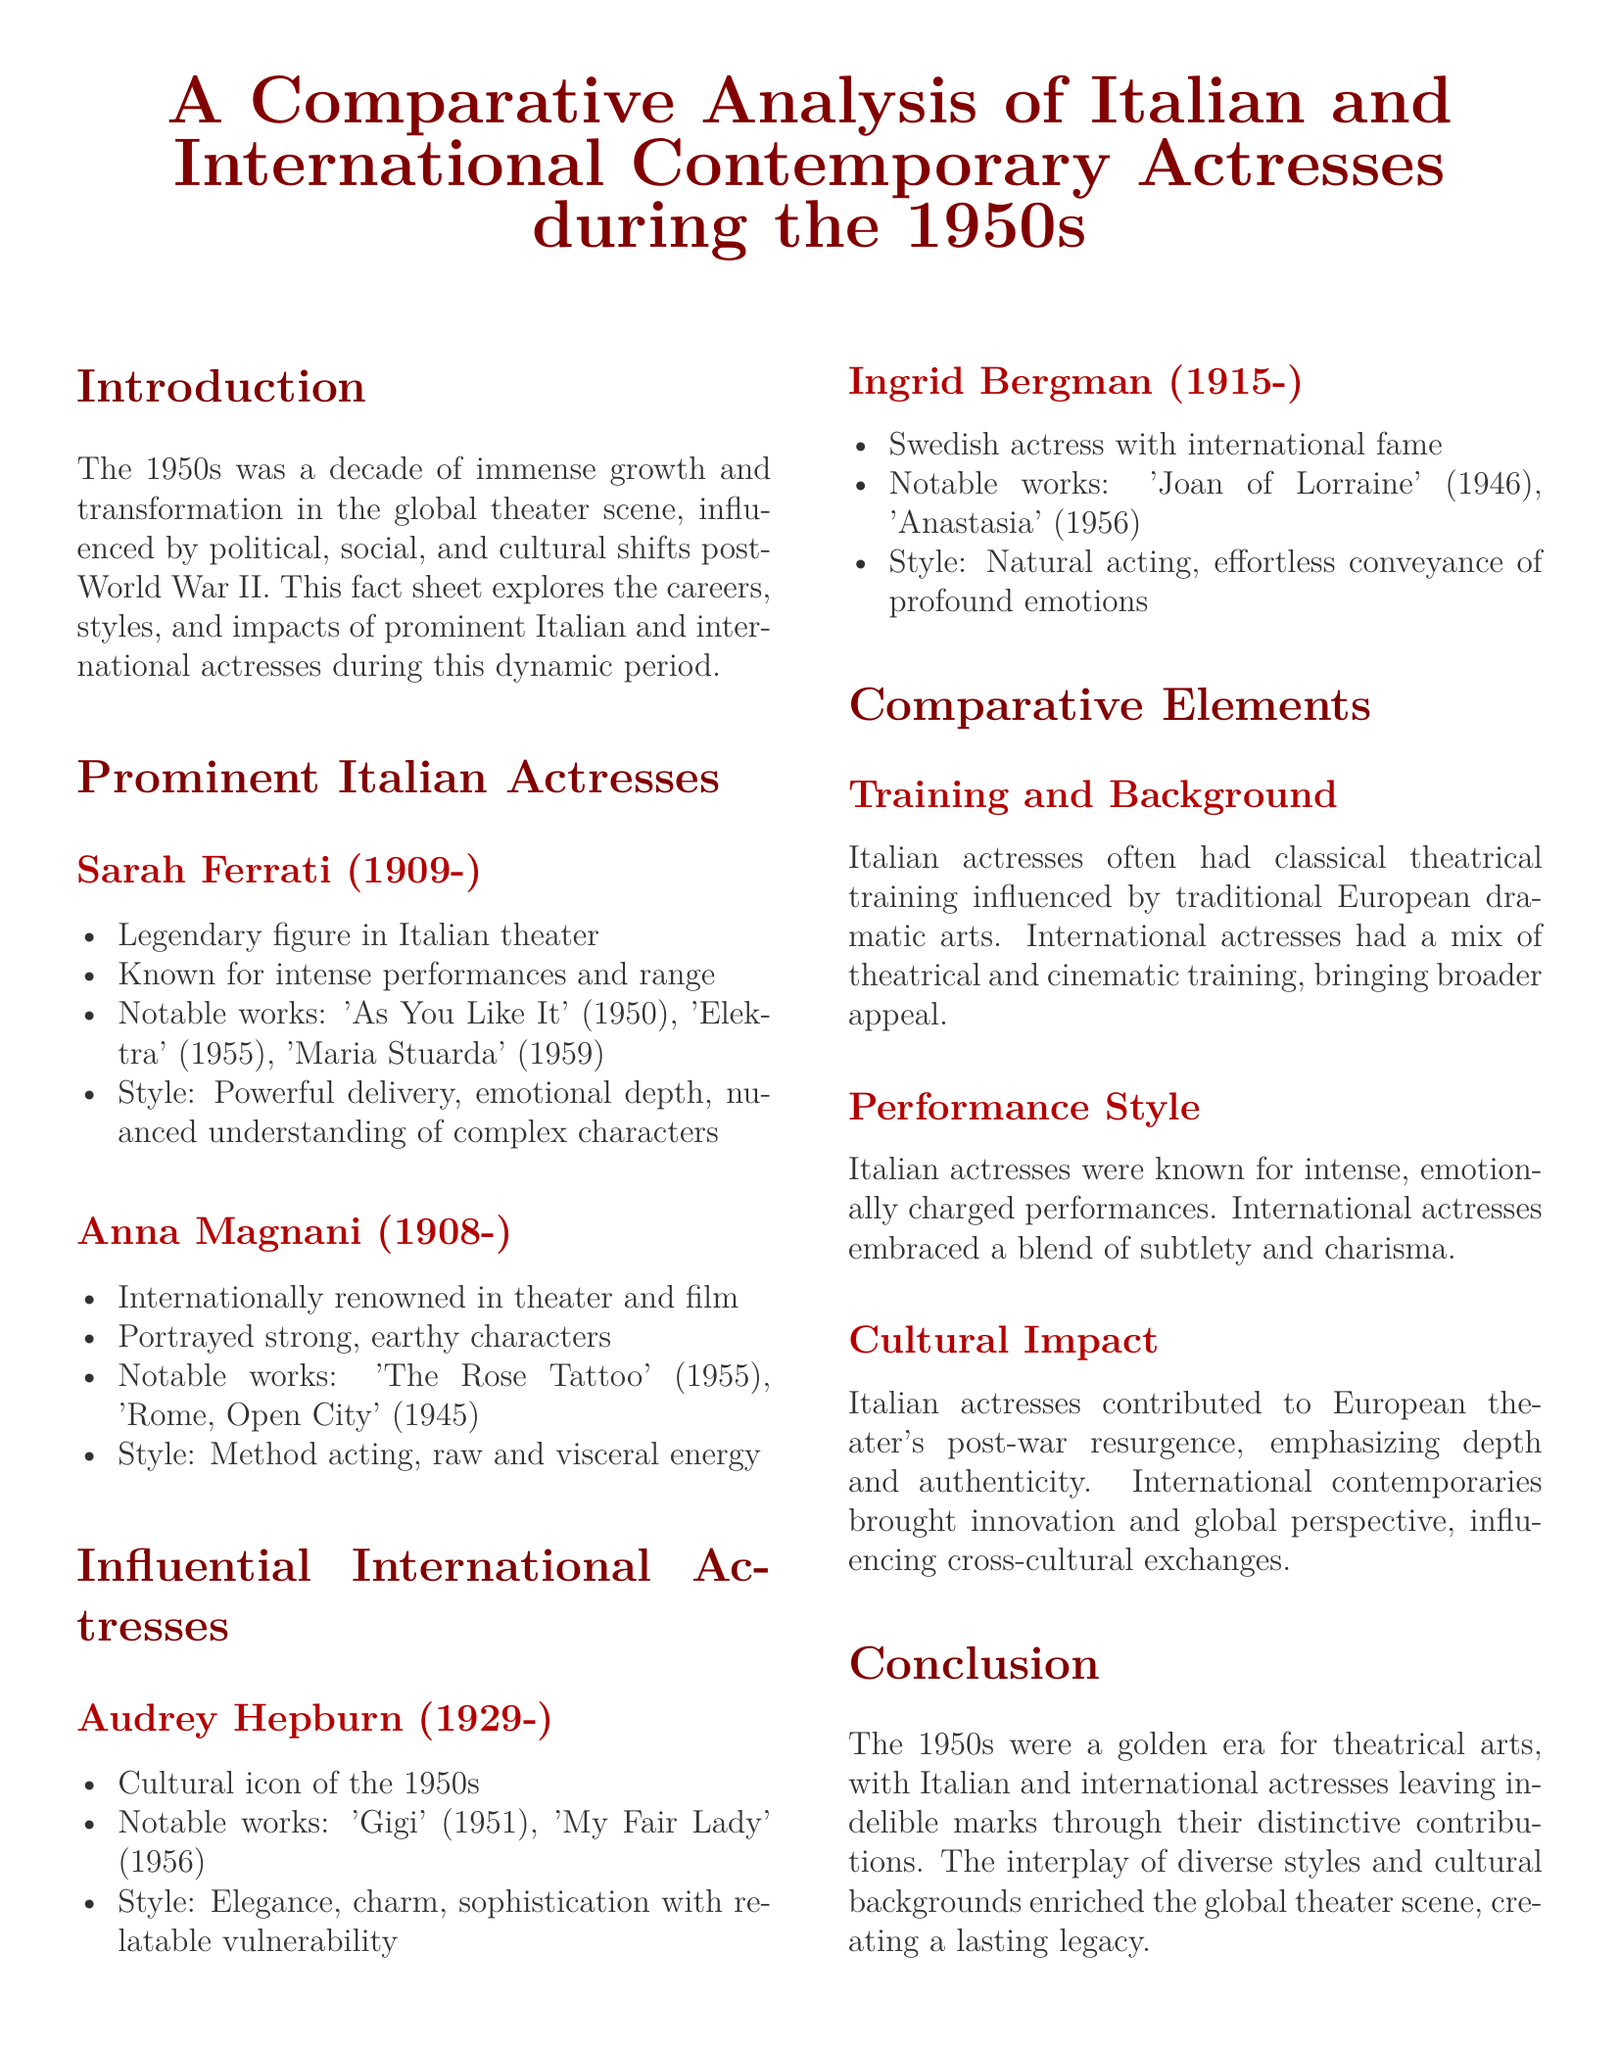What notable work did Sarah Ferrati perform in 1955? Sarah Ferrati is known for her performance in 'Elektra' during 1955, as listed in the document.
Answer: 'Elektra' Which actress portrayed strong, earthy characters? The document mentions Anna Magnani as the actress known for embodying strong, earthy characters.
Answer: Anna Magnani What year did Audrey Hepburn star in 'My Fair Lady'? The document states that Audrey Hepburn's notable work 'My Fair Lady' was from the year 1956.
Answer: 1956 Which acting style is associated with Italian actresses? The document identifies intense, emotionally charged performances as the performance style characteristic of Italian actresses.
Answer: Intense, emotionally charged performances What type of training did Italian actresses typically have? The document specifies that Italian actresses often had classical theatrical training influenced by traditional European dramatic arts.
Answer: Classical theatrical training What impact did Italian actresses have on European theater? According to the document, Italian actresses contributed to the post-war resurgence of European theater, emphasizing depth and authenticity.
Answer: Post-war resurgence Which actress is a cultural icon of the 1950s? The document refers to Audrey Hepburn as a cultural icon of the 1950s.
Answer: Audrey Hepburn What is a key feature of the performance style of international actresses? The document describes the performance style of international actresses as a blend of subtlety and charisma.
Answer: Blend of subtlety and charisma In which year was Anna Magnani internationally renowned? The document indicates that Anna Magnani was internationally renowned during the 1950s.
Answer: 1950s 